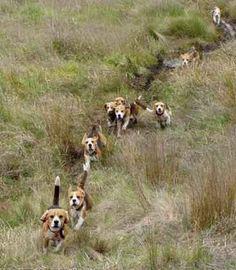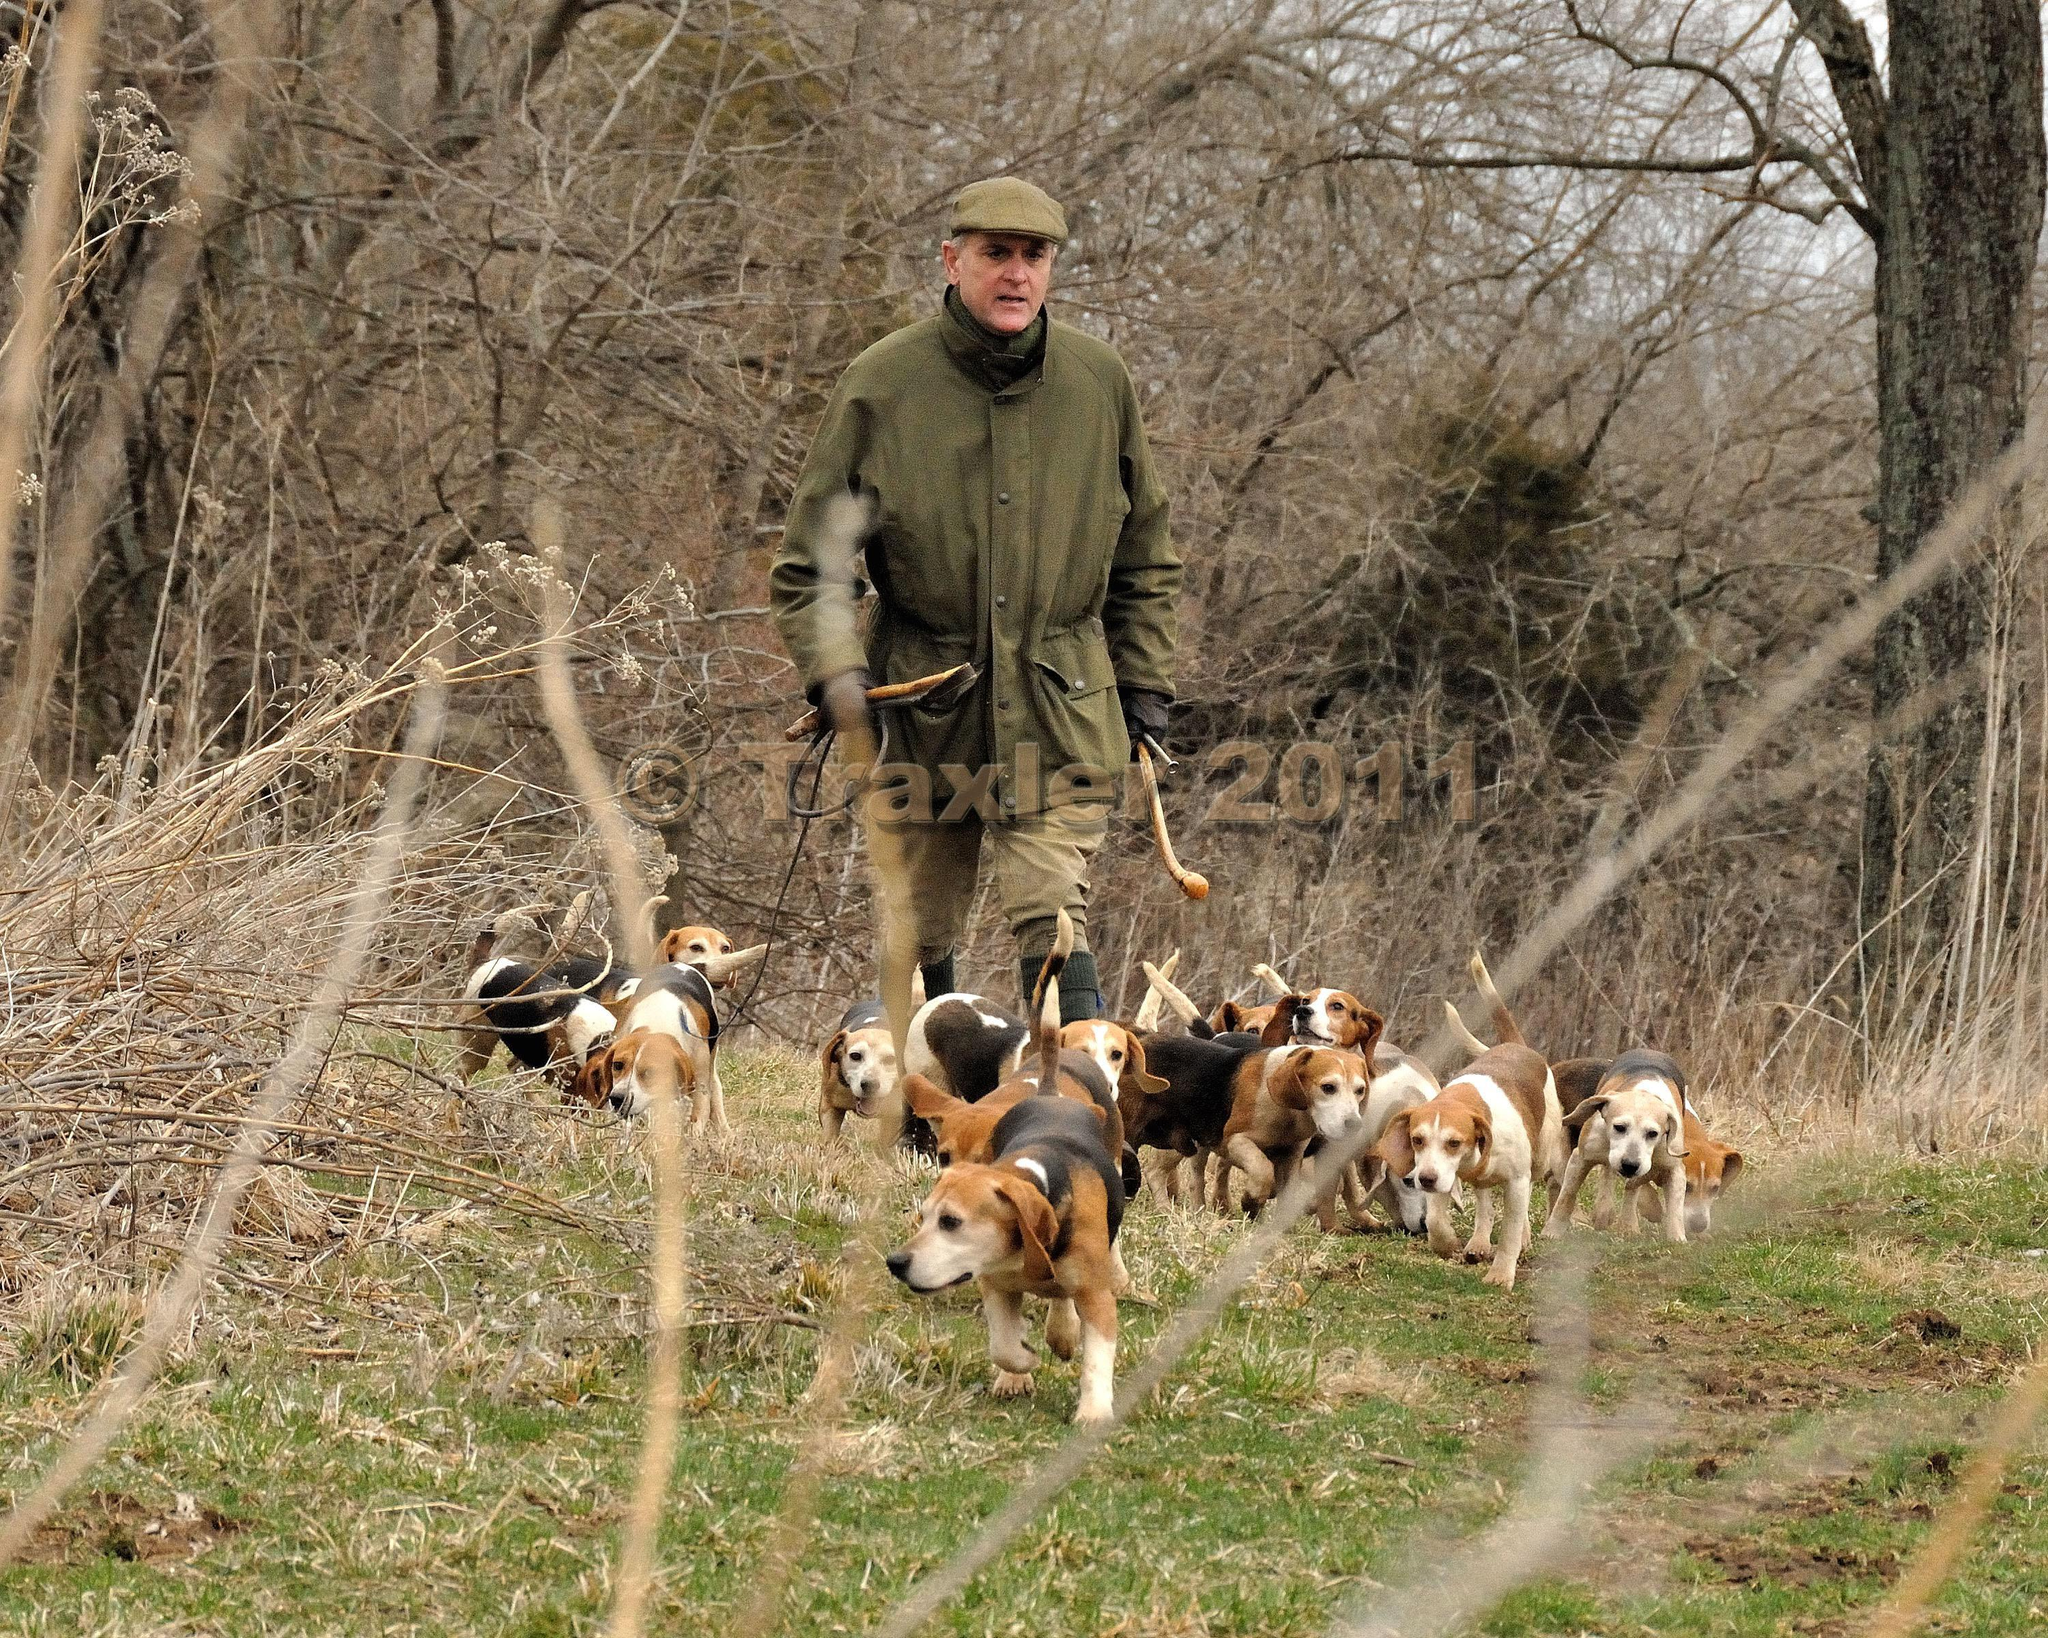The first image is the image on the left, the second image is the image on the right. For the images shown, is this caption "Each image shows a pack of dogs near a man in a blazer and cap holding a whip stick." true? Answer yes or no. No. The first image is the image on the left, the second image is the image on the right. Evaluate the accuracy of this statement regarding the images: "A white fence is visible behind a group of dogs.". Is it true? Answer yes or no. No. 